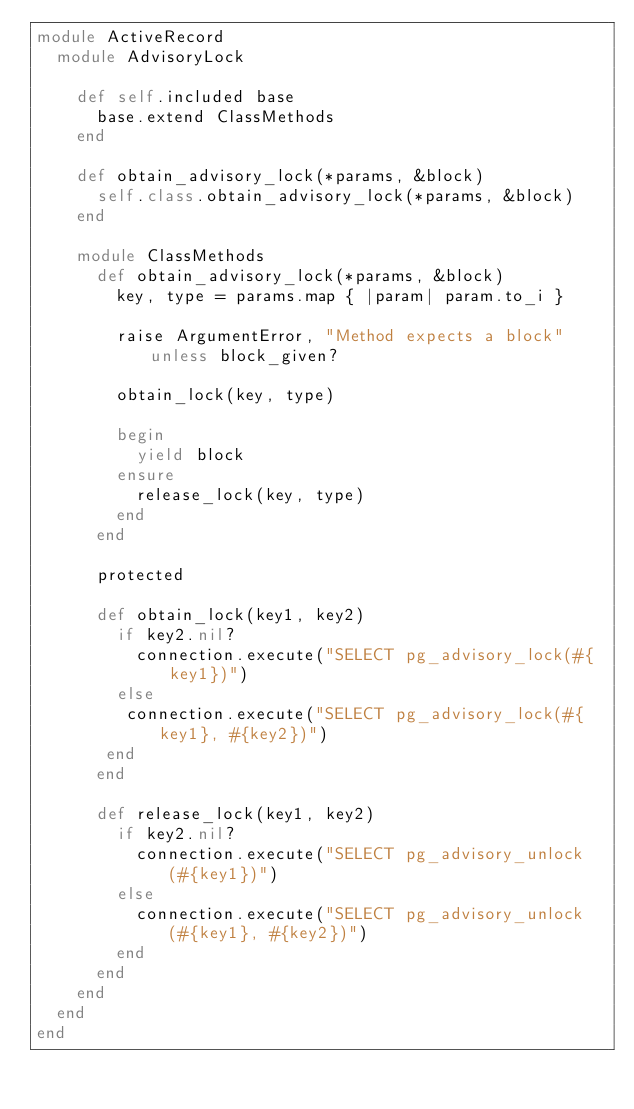<code> <loc_0><loc_0><loc_500><loc_500><_Ruby_>module ActiveRecord
  module AdvisoryLock

    def self.included base
      base.extend ClassMethods
    end

    def obtain_advisory_lock(*params, &block)
      self.class.obtain_advisory_lock(*params, &block)
    end

    module ClassMethods
      def obtain_advisory_lock(*params, &block)
        key, type = params.map { |param| param.to_i }

        raise ArgumentError, "Method expects a block" unless block_given?

        obtain_lock(key, type)

        begin
          yield block
        ensure
          release_lock(key, type)
        end
      end

      protected

      def obtain_lock(key1, key2)
        if key2.nil?
          connection.execute("SELECT pg_advisory_lock(#{key1})")
        else
         connection.execute("SELECT pg_advisory_lock(#{key1}, #{key2})")
       end
      end

      def release_lock(key1, key2)
        if key2.nil?
          connection.execute("SELECT pg_advisory_unlock(#{key1})")
        else
          connection.execute("SELECT pg_advisory_unlock(#{key1}, #{key2})")
        end
      end
    end
  end
end
</code> 